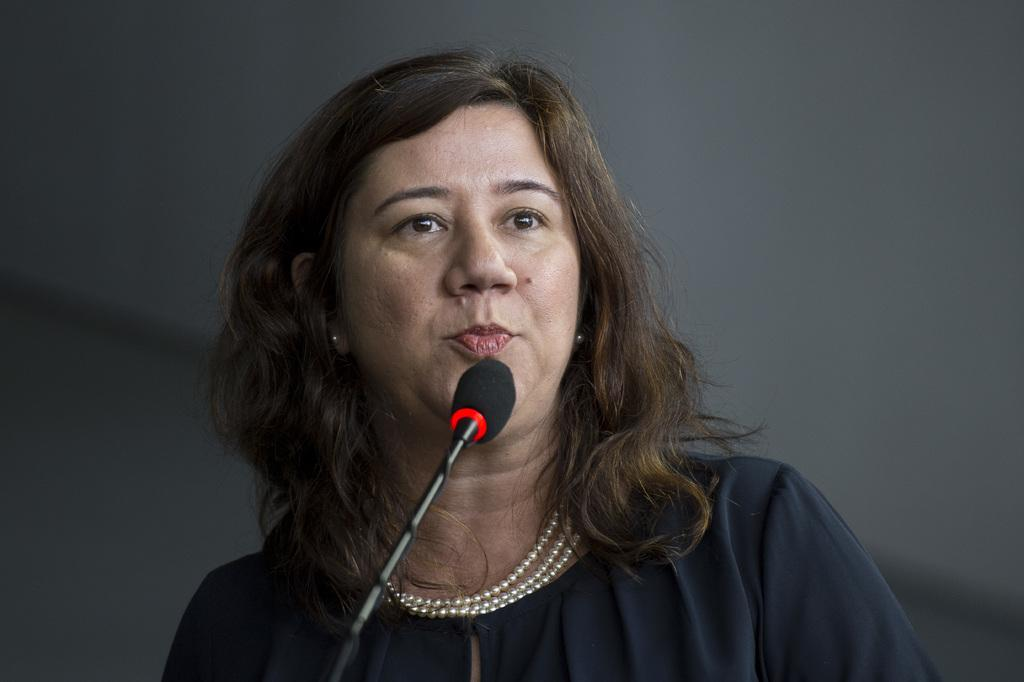Who is the main subject in the image? There is a woman in the image. What is the woman holding in the image? The woman is holding a microphone. What color is the dress the woman is wearing? The woman is wearing a black dress. What type of fowl can be seen flying in the background of the image? There is no fowl visible in the image; it only features a woman holding a microphone and wearing a black dress. 